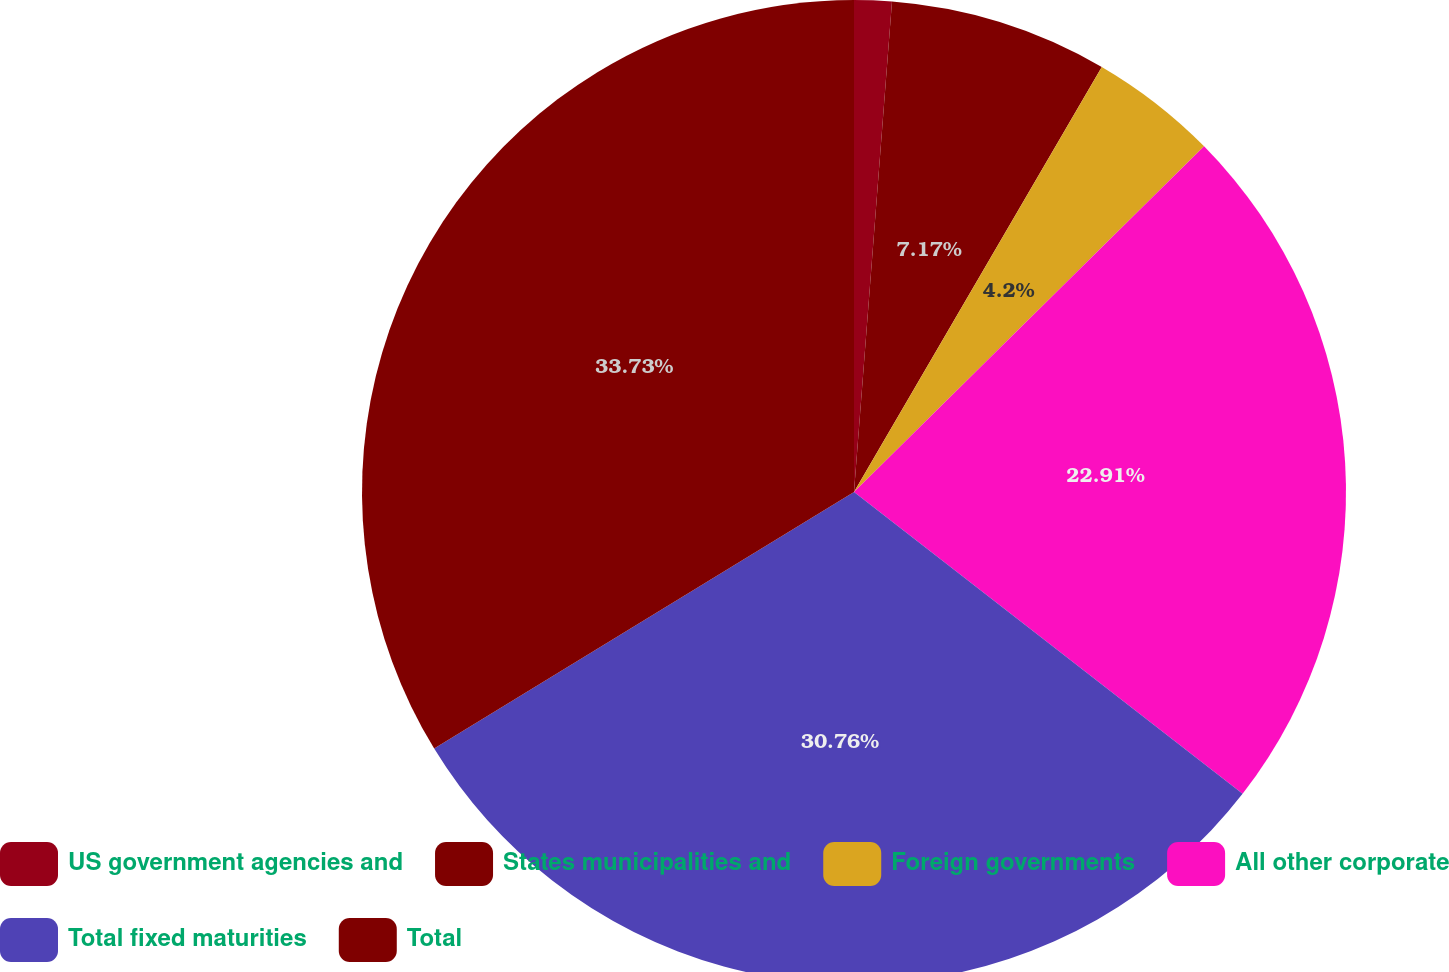<chart> <loc_0><loc_0><loc_500><loc_500><pie_chart><fcel>US government agencies and<fcel>States municipalities and<fcel>Foreign governments<fcel>All other corporate<fcel>Total fixed maturities<fcel>Total<nl><fcel>1.23%<fcel>7.17%<fcel>4.2%<fcel>22.91%<fcel>30.76%<fcel>33.73%<nl></chart> 